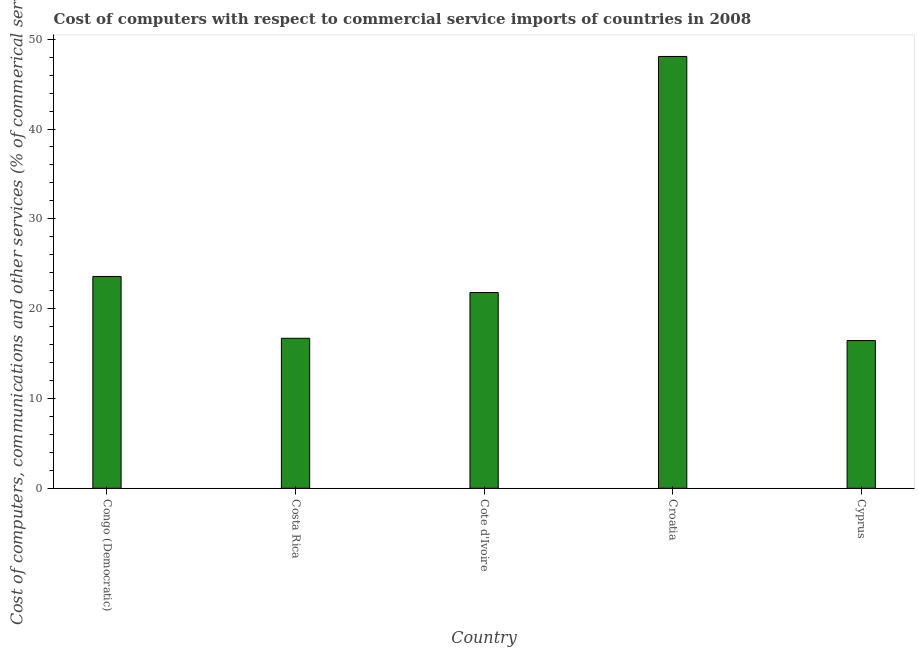Does the graph contain any zero values?
Provide a succinct answer. No. Does the graph contain grids?
Make the answer very short. No. What is the title of the graph?
Your answer should be compact. Cost of computers with respect to commercial service imports of countries in 2008. What is the label or title of the Y-axis?
Offer a very short reply. Cost of computers, communications and other services (% of commerical service exports). What is the  computer and other services in Costa Rica?
Offer a terse response. 16.7. Across all countries, what is the maximum  computer and other services?
Make the answer very short. 48.08. Across all countries, what is the minimum  computer and other services?
Provide a short and direct response. 16.45. In which country was the cost of communications maximum?
Your response must be concise. Croatia. In which country was the cost of communications minimum?
Keep it short and to the point. Cyprus. What is the sum of the cost of communications?
Make the answer very short. 126.61. What is the difference between the cost of communications in Congo (Democratic) and Cyprus?
Make the answer very short. 7.14. What is the average cost of communications per country?
Keep it short and to the point. 25.32. What is the median  computer and other services?
Provide a short and direct response. 21.8. In how many countries, is the  computer and other services greater than 36 %?
Offer a terse response. 1. What is the ratio of the  computer and other services in Cote d'Ivoire to that in Croatia?
Keep it short and to the point. 0.45. What is the difference between the highest and the second highest  computer and other services?
Keep it short and to the point. 24.5. Is the sum of the cost of communications in Cote d'Ivoire and Cyprus greater than the maximum cost of communications across all countries?
Give a very brief answer. No. What is the difference between the highest and the lowest cost of communications?
Your response must be concise. 31.63. How many bars are there?
Your answer should be very brief. 5. Are the values on the major ticks of Y-axis written in scientific E-notation?
Your response must be concise. No. What is the Cost of computers, communications and other services (% of commerical service exports) of Congo (Democratic)?
Provide a short and direct response. 23.58. What is the Cost of computers, communications and other services (% of commerical service exports) of Costa Rica?
Offer a terse response. 16.7. What is the Cost of computers, communications and other services (% of commerical service exports) of Cote d'Ivoire?
Keep it short and to the point. 21.8. What is the Cost of computers, communications and other services (% of commerical service exports) in Croatia?
Ensure brevity in your answer.  48.08. What is the Cost of computers, communications and other services (% of commerical service exports) in Cyprus?
Provide a short and direct response. 16.45. What is the difference between the Cost of computers, communications and other services (% of commerical service exports) in Congo (Democratic) and Costa Rica?
Provide a succinct answer. 6.88. What is the difference between the Cost of computers, communications and other services (% of commerical service exports) in Congo (Democratic) and Cote d'Ivoire?
Your answer should be very brief. 1.79. What is the difference between the Cost of computers, communications and other services (% of commerical service exports) in Congo (Democratic) and Croatia?
Provide a short and direct response. -24.5. What is the difference between the Cost of computers, communications and other services (% of commerical service exports) in Congo (Democratic) and Cyprus?
Your answer should be very brief. 7.14. What is the difference between the Cost of computers, communications and other services (% of commerical service exports) in Costa Rica and Cote d'Ivoire?
Make the answer very short. -5.1. What is the difference between the Cost of computers, communications and other services (% of commerical service exports) in Costa Rica and Croatia?
Provide a succinct answer. -31.38. What is the difference between the Cost of computers, communications and other services (% of commerical service exports) in Costa Rica and Cyprus?
Ensure brevity in your answer.  0.25. What is the difference between the Cost of computers, communications and other services (% of commerical service exports) in Cote d'Ivoire and Croatia?
Provide a succinct answer. -26.28. What is the difference between the Cost of computers, communications and other services (% of commerical service exports) in Cote d'Ivoire and Cyprus?
Keep it short and to the point. 5.35. What is the difference between the Cost of computers, communications and other services (% of commerical service exports) in Croatia and Cyprus?
Your answer should be compact. 31.63. What is the ratio of the Cost of computers, communications and other services (% of commerical service exports) in Congo (Democratic) to that in Costa Rica?
Keep it short and to the point. 1.41. What is the ratio of the Cost of computers, communications and other services (% of commerical service exports) in Congo (Democratic) to that in Cote d'Ivoire?
Provide a short and direct response. 1.08. What is the ratio of the Cost of computers, communications and other services (% of commerical service exports) in Congo (Democratic) to that in Croatia?
Keep it short and to the point. 0.49. What is the ratio of the Cost of computers, communications and other services (% of commerical service exports) in Congo (Democratic) to that in Cyprus?
Offer a terse response. 1.43. What is the ratio of the Cost of computers, communications and other services (% of commerical service exports) in Costa Rica to that in Cote d'Ivoire?
Your response must be concise. 0.77. What is the ratio of the Cost of computers, communications and other services (% of commerical service exports) in Costa Rica to that in Croatia?
Ensure brevity in your answer.  0.35. What is the ratio of the Cost of computers, communications and other services (% of commerical service exports) in Cote d'Ivoire to that in Croatia?
Give a very brief answer. 0.45. What is the ratio of the Cost of computers, communications and other services (% of commerical service exports) in Cote d'Ivoire to that in Cyprus?
Your answer should be very brief. 1.32. What is the ratio of the Cost of computers, communications and other services (% of commerical service exports) in Croatia to that in Cyprus?
Your response must be concise. 2.92. 